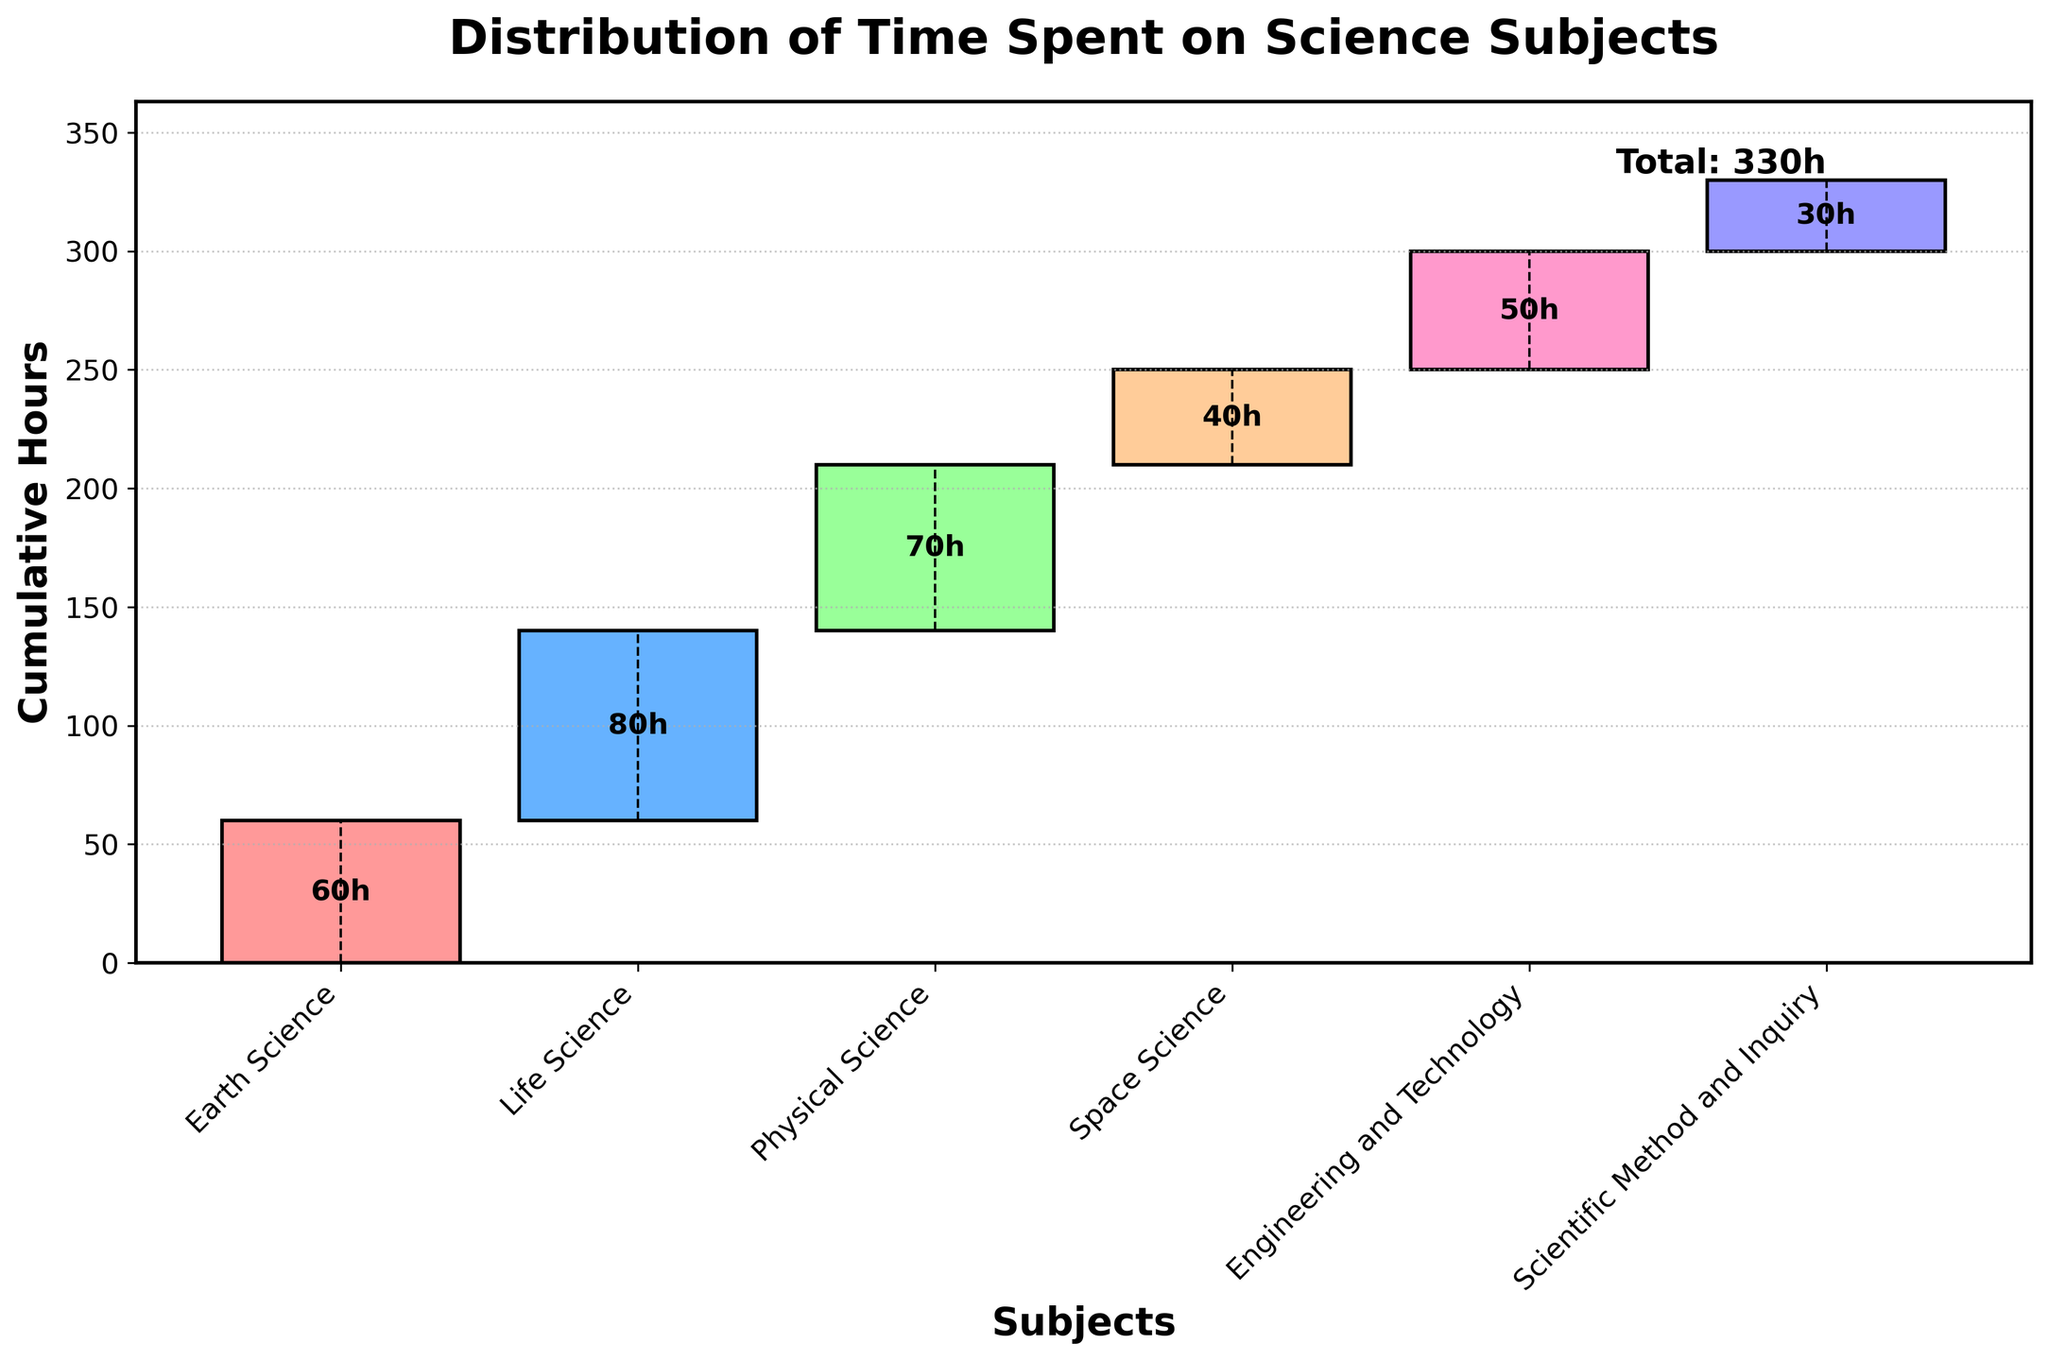What is the title of the chart? The title of the chart is displayed prominently at the top of the chart.
Answer: Distribution of Time Spent on Science Subjects How many different science subjects are represented in the chart? Each bar represents a different science subject on the x-axis. Count the number of bars.
Answer: 6 Which science subject has the highest number of hours? Look for the tallest bar in the chart, indicating the maximum number of hours spent on that subject.
Answer: Life Science What is the total cumulative time spent on all science subjects? According to the chart, the cumulative time is shown at the end of the chart under the label "Total."
Answer: 330 hours How many hours are spent on Space Science? Look for the bar labeled "Space Science" and find the value associated with it, usually displayed within or on top of the bar.
Answer: 40 hours Which subject has the least time spent on it? Find the shortest bar in the chart. This represents the subject with the minimum time spent.
Answer: Scientific Method and Inquiry How many more hours are spent on Earth Science compared to Engineering and Technology? Find the number of hours for Earth Science and Engineering and Technology, then subtract the smaller from the larger.
Answer: 10 more hours What is the average time spent on all subjects excluding the start and end points? Sum the hours spent on each subject and divide by the number of subjects. (60 + 80 + 70 + 40 + 50 + 30) / 6
Answer: 55 hours Which subject comes immediately after Life Science in the order of hours spent? Examine the sequence of bars starting from the one labeled "Life Science" to find the next one.
Answer: Physical Science Are there more hours spent on Engineering and Technology or on Physical Science? Compare the height of the bars corresponding to Engineering and Technology and Physical Science.
Answer: Physical Science 